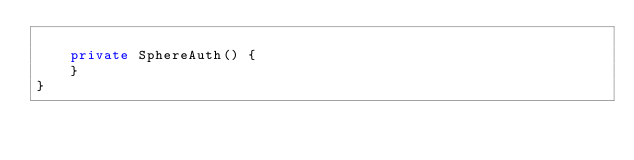Convert code to text. <code><loc_0><loc_0><loc_500><loc_500><_Java_>
    private SphereAuth() {
    }
}
</code> 